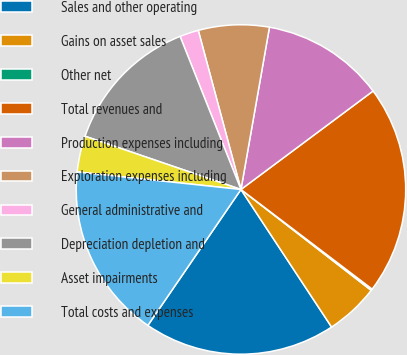Convert chart to OTSL. <chart><loc_0><loc_0><loc_500><loc_500><pie_chart><fcel>Sales and other operating<fcel>Gains on asset sales<fcel>Other net<fcel>Total revenues and<fcel>Production expenses including<fcel>Exploration expenses including<fcel>General administrative and<fcel>Depreciation depletion and<fcel>Asset impairments<fcel>Total costs and expenses<nl><fcel>18.83%<fcel>5.24%<fcel>0.15%<fcel>20.53%<fcel>12.04%<fcel>6.94%<fcel>1.85%<fcel>13.74%<fcel>3.54%<fcel>17.14%<nl></chart> 